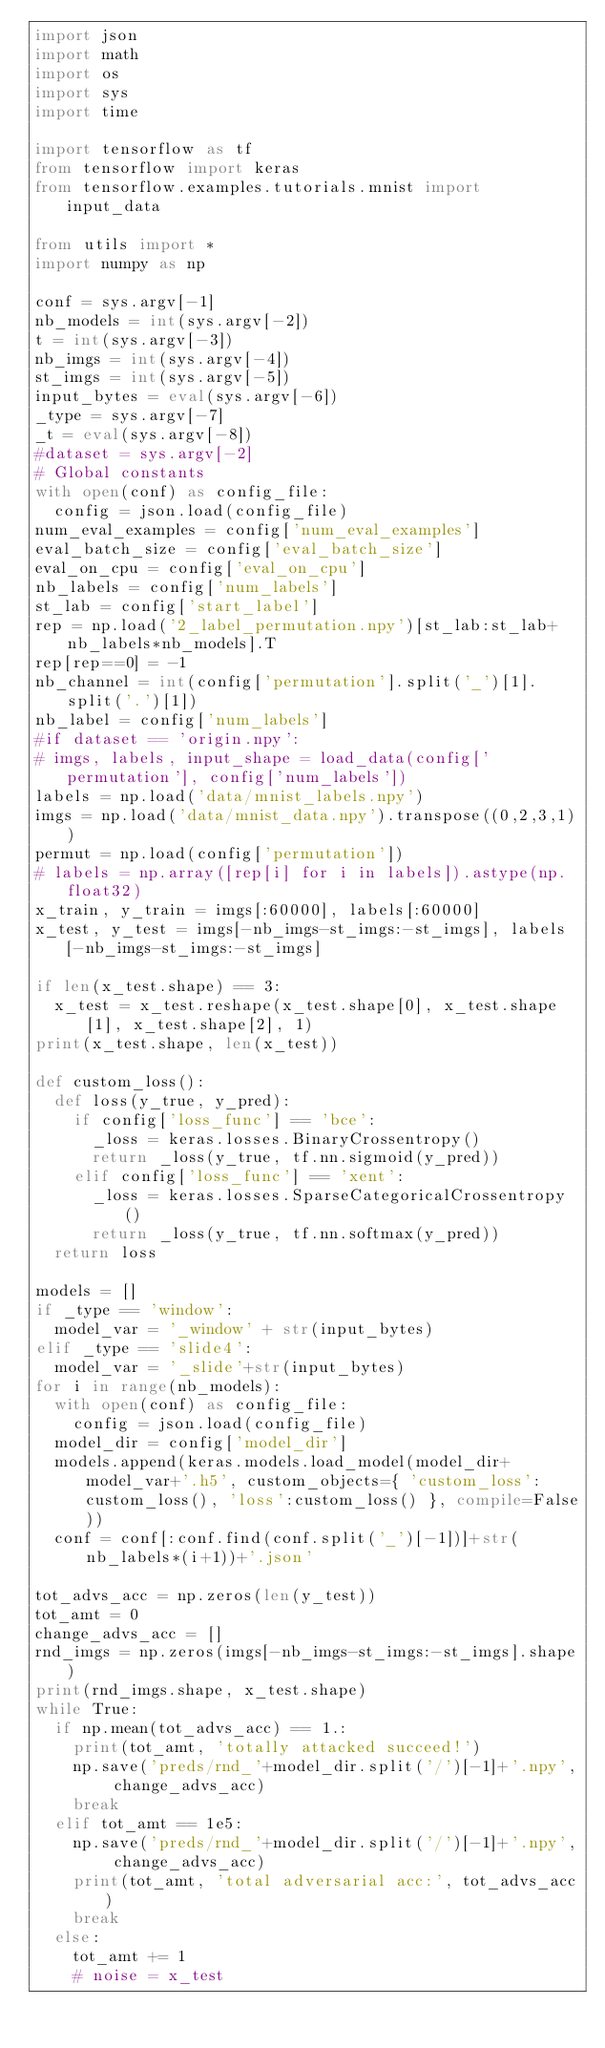<code> <loc_0><loc_0><loc_500><loc_500><_Python_>import json
import math
import os
import sys
import time

import tensorflow as tf
from tensorflow import keras
from tensorflow.examples.tutorials.mnist import input_data

from utils import *
import numpy as np

conf = sys.argv[-1]
nb_models = int(sys.argv[-2])
t = int(sys.argv[-3])
nb_imgs = int(sys.argv[-4])
st_imgs = int(sys.argv[-5])
input_bytes = eval(sys.argv[-6])
_type = sys.argv[-7]
_t = eval(sys.argv[-8])
#dataset = sys.argv[-2]
# Global constants
with open(conf) as config_file:
  config = json.load(config_file)
num_eval_examples = config['num_eval_examples']
eval_batch_size = config['eval_batch_size']
eval_on_cpu = config['eval_on_cpu']
nb_labels = config['num_labels']
st_lab = config['start_label']
rep = np.load('2_label_permutation.npy')[st_lab:st_lab+nb_labels*nb_models].T
rep[rep==0] = -1
nb_channel = int(config['permutation'].split('_')[1].split('.')[1])
nb_label = config['num_labels']
#if dataset == 'origin.npy':
# imgs, labels, input_shape = load_data(config['permutation'], config['num_labels'])
labels = np.load('data/mnist_labels.npy')
imgs = np.load('data/mnist_data.npy').transpose((0,2,3,1))
permut = np.load(config['permutation'])
# labels = np.array([rep[i] for i in labels]).astype(np.float32)
x_train, y_train = imgs[:60000], labels[:60000]
x_test, y_test = imgs[-nb_imgs-st_imgs:-st_imgs], labels[-nb_imgs-st_imgs:-st_imgs]

if len(x_test.shape) == 3:
  x_test = x_test.reshape(x_test.shape[0], x_test.shape[1], x_test.shape[2], 1)
print(x_test.shape, len(x_test))

def custom_loss():
  def loss(y_true, y_pred):
    if config['loss_func'] == 'bce':
      _loss = keras.losses.BinaryCrossentropy()
      return _loss(y_true, tf.nn.sigmoid(y_pred))
    elif config['loss_func'] == 'xent':
      _loss = keras.losses.SparseCategoricalCrossentropy()
      return _loss(y_true, tf.nn.softmax(y_pred))
  return loss

models = []
if _type == 'window':
  model_var = '_window' + str(input_bytes)
elif _type == 'slide4':
  model_var = '_slide'+str(input_bytes)
for i in range(nb_models):
  with open(conf) as config_file:
    config = json.load(config_file)
  model_dir = config['model_dir']
  models.append(keras.models.load_model(model_dir+model_var+'.h5', custom_objects={ 'custom_loss': custom_loss(), 'loss':custom_loss() }, compile=False))
  conf = conf[:conf.find(conf.split('_')[-1])]+str(nb_labels*(i+1))+'.json'

tot_advs_acc = np.zeros(len(y_test))
tot_amt = 0
change_advs_acc = []
rnd_imgs = np.zeros(imgs[-nb_imgs-st_imgs:-st_imgs].shape)
print(rnd_imgs.shape, x_test.shape)
while True:
  if np.mean(tot_advs_acc) == 1.: 
    print(tot_amt, 'totally attacked succeed!')
    np.save('preds/rnd_'+model_dir.split('/')[-1]+'.npy', change_advs_acc)
    break
  elif tot_amt == 1e5:
    np.save('preds/rnd_'+model_dir.split('/')[-1]+'.npy', change_advs_acc)
    print(tot_amt, 'total adversarial acc:', tot_advs_acc)
    break
  else:
    tot_amt += 1
    # noise = x_test</code> 